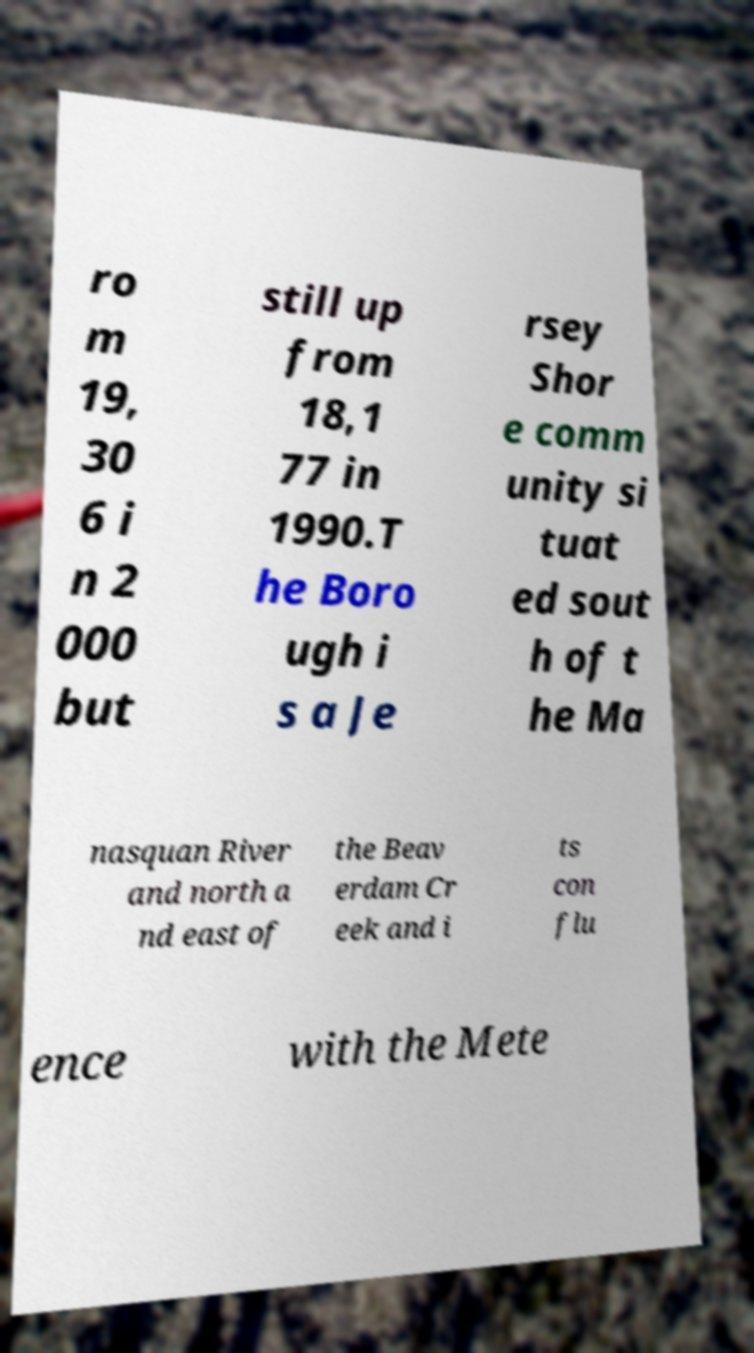Can you accurately transcribe the text from the provided image for me? ro m 19, 30 6 i n 2 000 but still up from 18,1 77 in 1990.T he Boro ugh i s a Je rsey Shor e comm unity si tuat ed sout h of t he Ma nasquan River and north a nd east of the Beav erdam Cr eek and i ts con flu ence with the Mete 